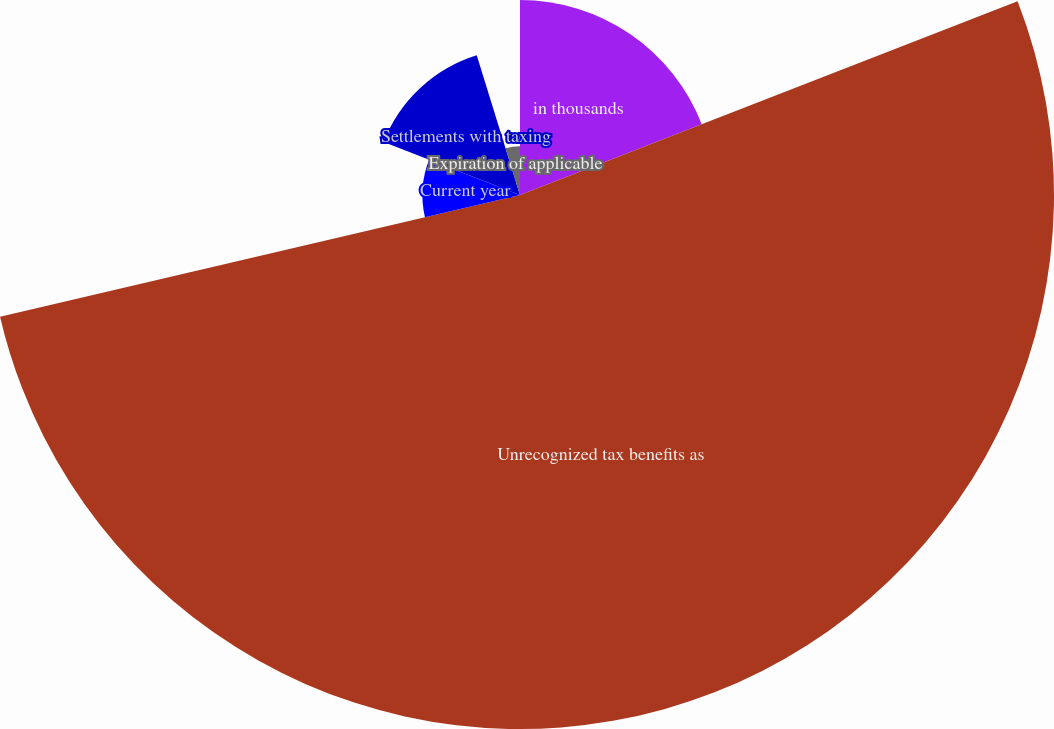Convert chart. <chart><loc_0><loc_0><loc_500><loc_500><pie_chart><fcel>in thousands<fcel>Unrecognized tax benefits as<fcel>Prior years<fcel>Current year<fcel>Settlements with taxing<fcel>Expiration of applicable<nl><fcel>19.09%<fcel>52.26%<fcel>0.01%<fcel>9.55%<fcel>14.32%<fcel>4.78%<nl></chart> 